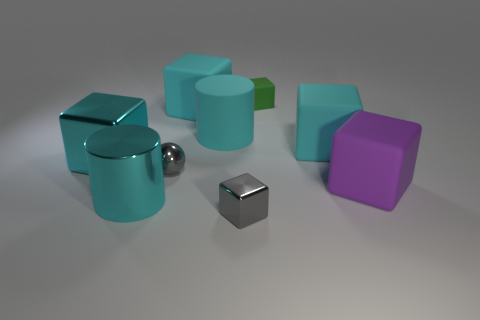Is the color of the metal cylinder the same as the big metal cube?
Give a very brief answer. Yes. Is there anything else that has the same color as the small sphere?
Your response must be concise. Yes. What number of cyan metallic cylinders are there?
Provide a short and direct response. 1. There is a object that is both right of the small green rubber cube and behind the shiny ball; what is its shape?
Ensure brevity in your answer.  Cube. There is a cyan thing that is behind the big cyan cylinder right of the gray thing left of the rubber cylinder; what shape is it?
Make the answer very short. Cube. What material is the big object that is both in front of the big metal cube and left of the large purple block?
Offer a very short reply. Metal. What number of metallic things have the same size as the matte cylinder?
Your answer should be compact. 2. How many shiny objects are either purple blocks or large brown blocks?
Make the answer very short. 0. What is the material of the tiny ball?
Offer a terse response. Metal. What number of tiny blocks are right of the small gray ball?
Keep it short and to the point. 2. 